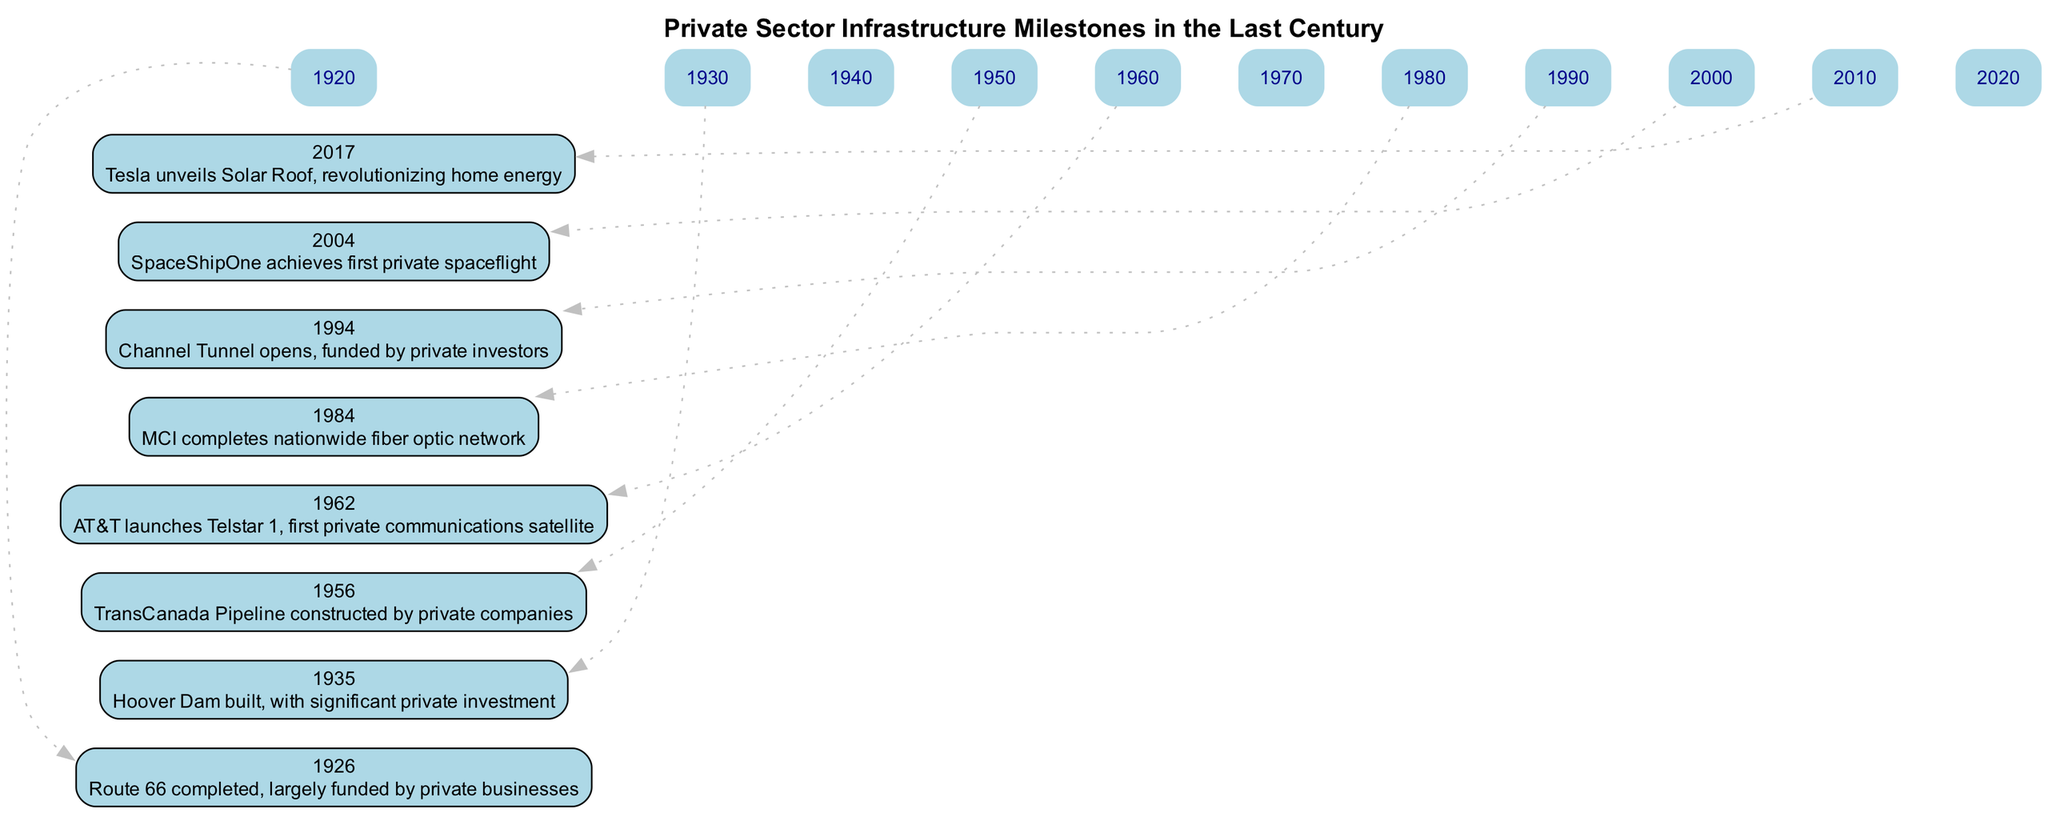What year was Route 66 completed? The diagram specifically states the event 'Route 66 completed' occurred in the year 1926.
Answer: 1926 Which event occurred in 1994? Looking at the timeline, the event listed for 1994 is 'Channel Tunnel opens, funded by private investors.'
Answer: Channel Tunnel opens, funded by private investors How many infrastructure developments are shown in the diagram? By counting the individual events listed in the timeline, there are a total of 8 distinct infrastructure developments.
Answer: 8 What is the earliest event in the diagram? The earliest event listed in the timeline is the completion of Route 66 in 1926, making it the first event shown.
Answer: Route 66 completed, largely funded by private businesses Which event marks the achievement of the first private spaceflight? According to the timeline, 'SpaceShipOne achieves first private spaceflight' marks that achievement, occurring in the year 2004.
Answer: SpaceShipOne achieves first private spaceflight What decade did the MCI nationwide fiber optic network get completed? By looking at the year associated with that event, which is 1984, we can determine it occurred in the 1980s decade.
Answer: 1980s What type of investment funded the Hoover Dam? The diagram states that the Hoover Dam was built with 'significant private investment,' indicating the type of funding.
Answer: significant private investment Which two events occurred in the 1960s and 1990s? The timeline shows that in the 1960s, AT&T launches Telstar 1, and in the 1990s, Channel Tunnel opens, providing the events for those decades.
Answer: AT&T launches Telstar 1, Channel Tunnel opens, funded by private investors What was revolutionary about the Tesla Solar Roof introduced in 2017? The description for the event in the timeline states that the Tesla Solar Roof 'revolutionized home energy,' indicating its significance.
Answer: revolutionizing home energy 